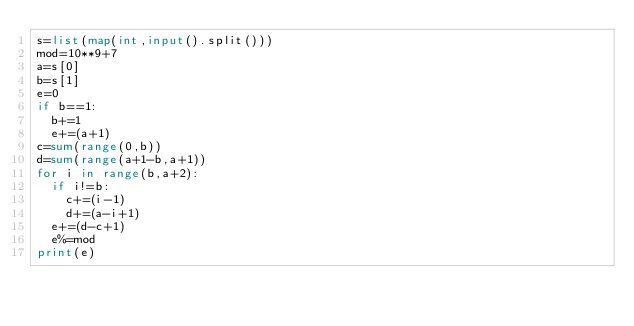Convert code to text. <code><loc_0><loc_0><loc_500><loc_500><_Python_>s=list(map(int,input().split()))
mod=10**9+7
a=s[0]
b=s[1]
e=0
if b==1:
  b+=1
  e+=(a+1)
c=sum(range(0,b))
d=sum(range(a+1-b,a+1))
for i in range(b,a+2):
  if i!=b:
    c+=(i-1)
    d+=(a-i+1)
  e+=(d-c+1)
  e%=mod
print(e)</code> 